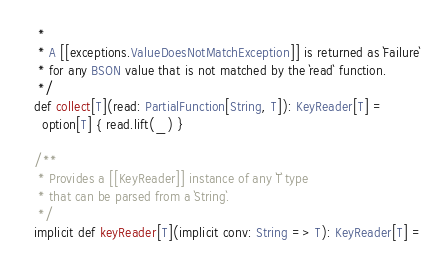<code> <loc_0><loc_0><loc_500><loc_500><_Scala_>   *
   * A [[exceptions.ValueDoesNotMatchException]] is returned as `Failure`
   * for any BSON value that is not matched by the `read` function.
   */
  def collect[T](read: PartialFunction[String, T]): KeyReader[T] =
    option[T] { read.lift(_) }

  /**
   * Provides a [[KeyReader]] instance of any `T` type
   * that can be parsed from a `String`.
   */
  implicit def keyReader[T](implicit conv: String => T): KeyReader[T] =</code> 